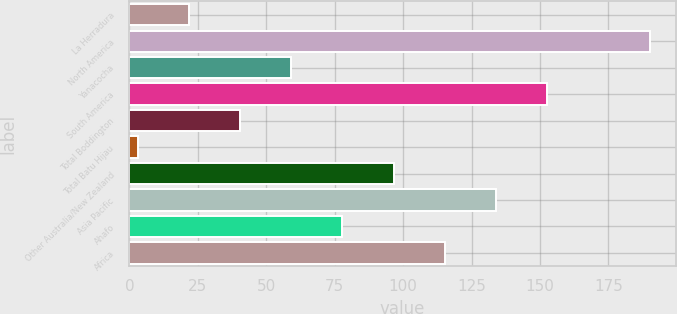Convert chart to OTSL. <chart><loc_0><loc_0><loc_500><loc_500><bar_chart><fcel>La Herradura<fcel>North America<fcel>Yanacocha<fcel>South America<fcel>Total Boddington<fcel>Total Batu Hijau<fcel>Other Australia/New Zealand<fcel>Asia Pacific<fcel>Ahafo<fcel>Africa<nl><fcel>21.7<fcel>190<fcel>59.1<fcel>152.6<fcel>40.4<fcel>3<fcel>96.5<fcel>133.9<fcel>77.8<fcel>115.2<nl></chart> 